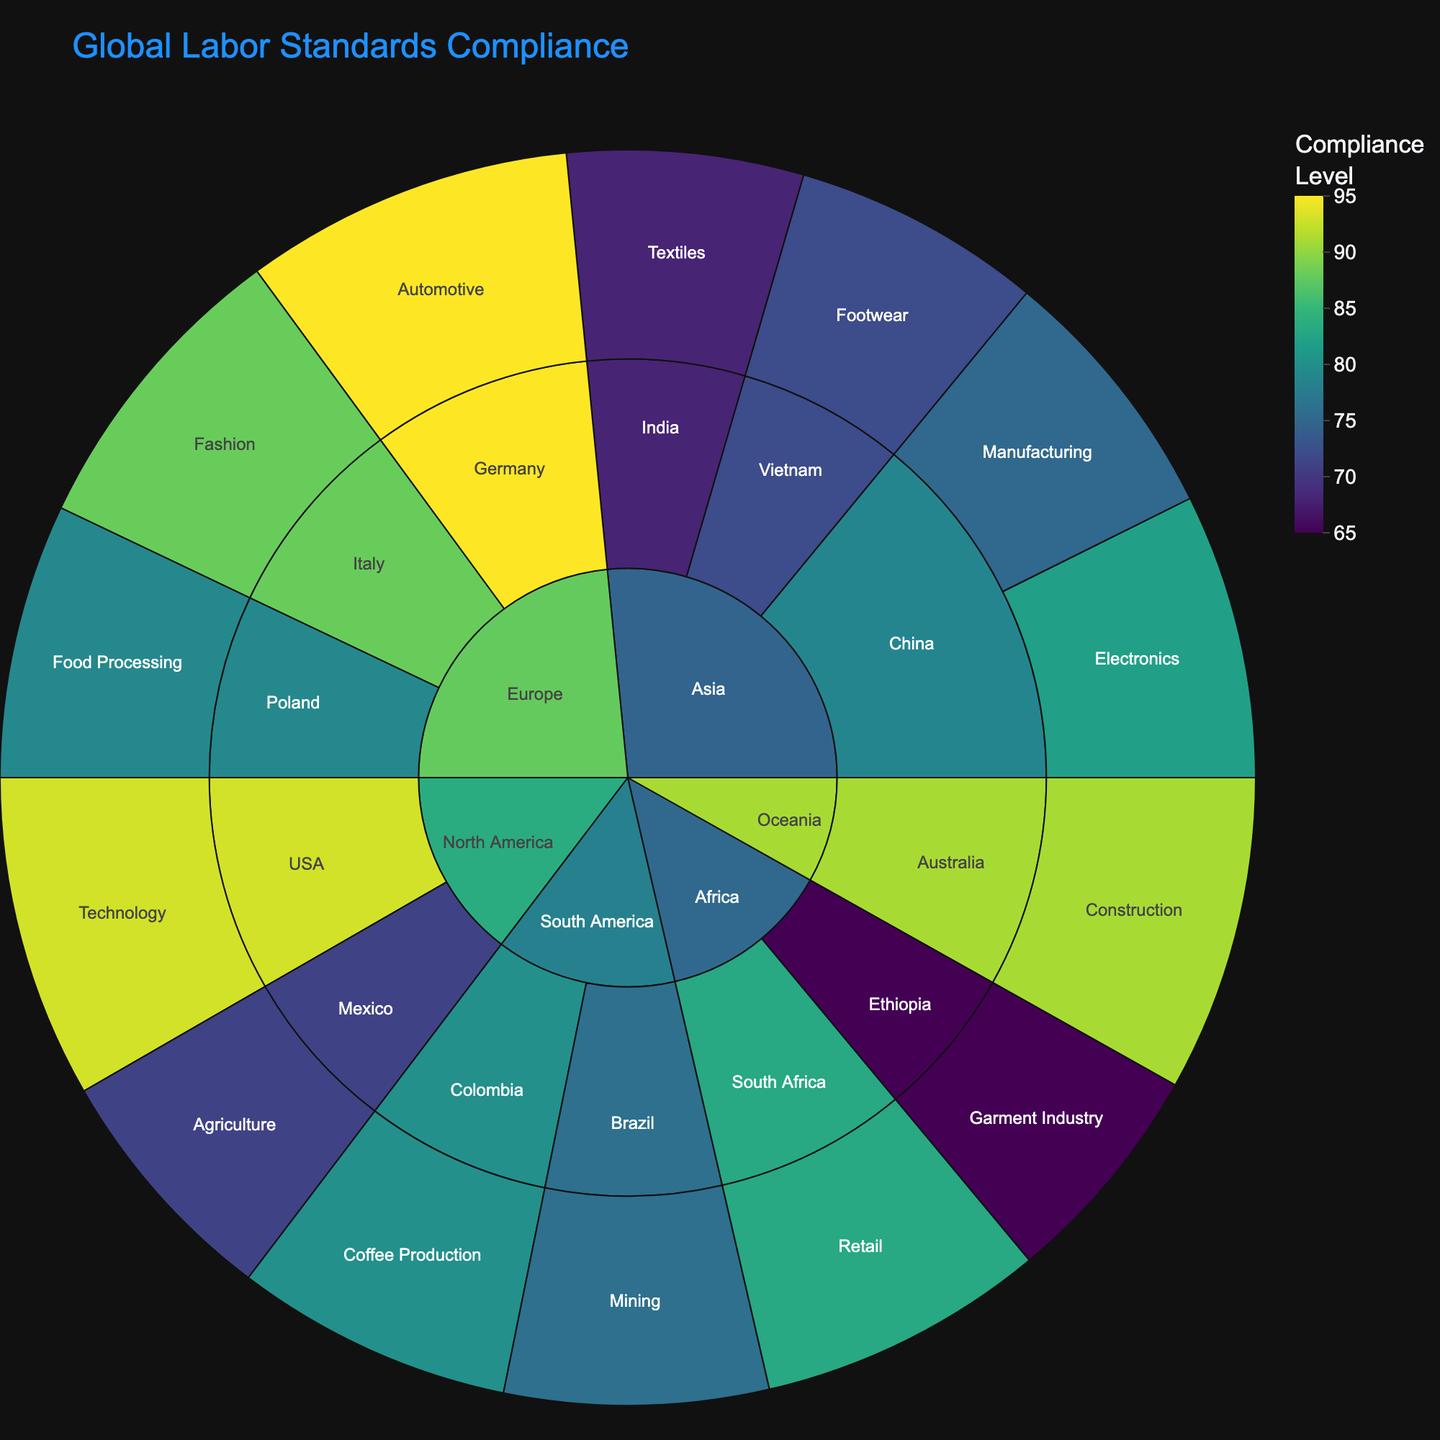What is the compliance level for the Automotive industry in Germany? The sunburst plot shows the compliance levels for each industry within countries. You can locate Germany, then find the Automotive industry segment, and read the compliance level.
Answer: 95 Which region has the highest compliance level? You need to examine the outer layers of each region and identify the one with the highest compliance level. Higher values in the color bar and depicted colors indicate higher compliance levels.
Answer: Europe How many industries are represented in North America? Start from the North America region, then count the individual industry segments within it.
Answer: 2 What is the average compliance level for the Asian countries? To find the average, note the compliance levels for China (75, 82), India (68), and Vietnam (72). Sum these values and divide by the number of industries. Average = (75 + 82 + 68 + 72) / 4
Answer: 74.25 Which country in Africa has the highest compliance level and what is it? Find the Africa region, then compare the compliance levels of individual countries. Identify the highest one.
Answer: South Africa with 83 Are there more industry sectors with compliance levels above 80% in Europe or Asia? Count the number of industry sectors with compliance levels above 80% for both Europe and Asia and compare the results. Europe has Fashion (88) and Automotive (95), while Asia has Electronics (82). Two industries in Europe, one in Asia.
Answer: Europe Which industry in Oceania has a compliance level? Locate the Oceania region and identify the industry segment within it and its compliance level.
Answer: Construction with 91 What is the total cumulative compliance level for all industries in South America? Add up the compliance levels of each industry in South America: Brazil (76) and Colombia (80). Total = 76 + 80
Answer: 156 What color range indicates lower compliance levels on the plot? Observe the color scales in the sunburst plot. The lower compliance levels are typically indicated by colors at the lower end of the continuous color scale (e.g., darker shades in the 'viridis' scale).
Answer: Darker shades Between manufacturing in China and garment industry in Ethiopia, which has a higher compliance level? Compare the compliance levels of the Manufacturing sector in China (75) and the Garment Industry in Ethiopia (65).
Answer: Manufacturing in China 